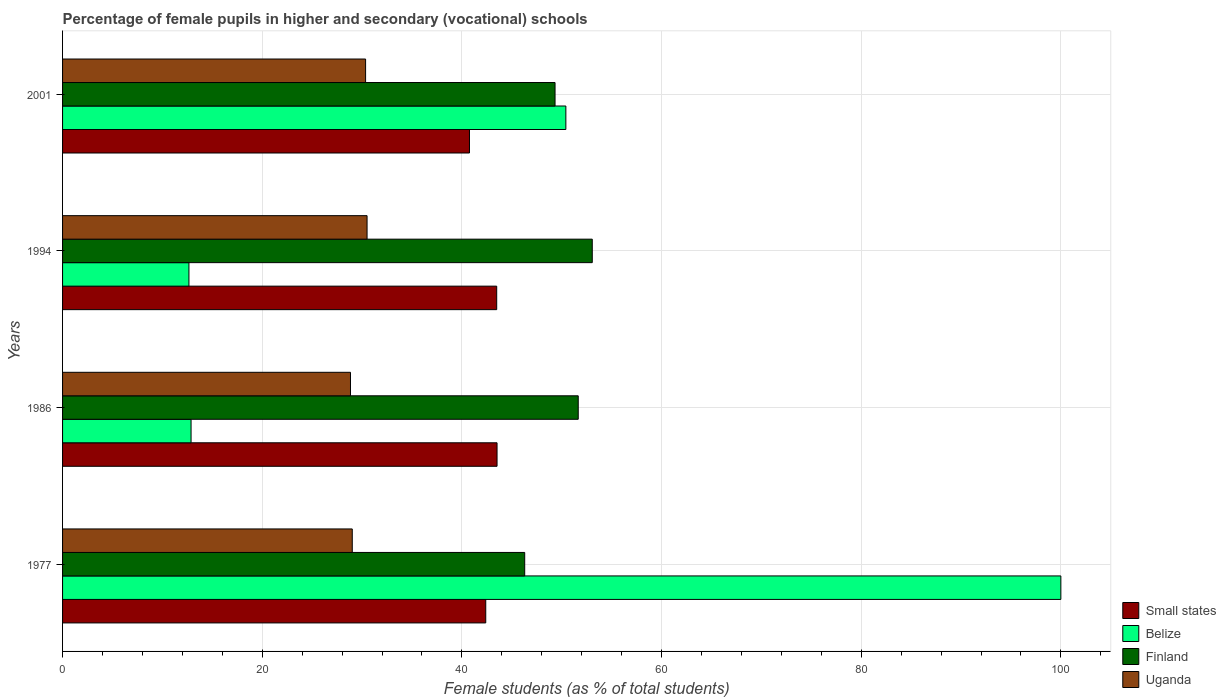Are the number of bars per tick equal to the number of legend labels?
Your answer should be very brief. Yes. Are the number of bars on each tick of the Y-axis equal?
Your response must be concise. Yes. What is the label of the 1st group of bars from the top?
Provide a short and direct response. 2001. In how many cases, is the number of bars for a given year not equal to the number of legend labels?
Provide a short and direct response. 0. What is the percentage of female pupils in higher and secondary schools in Uganda in 1977?
Offer a very short reply. 29.02. Across all years, what is the maximum percentage of female pupils in higher and secondary schools in Small states?
Offer a very short reply. 43.52. Across all years, what is the minimum percentage of female pupils in higher and secondary schools in Belize?
Keep it short and to the point. 12.66. In which year was the percentage of female pupils in higher and secondary schools in Belize maximum?
Provide a succinct answer. 1977. In which year was the percentage of female pupils in higher and secondary schools in Belize minimum?
Give a very brief answer. 1994. What is the total percentage of female pupils in higher and secondary schools in Uganda in the graph?
Your response must be concise. 118.72. What is the difference between the percentage of female pupils in higher and secondary schools in Uganda in 1977 and that in 1986?
Keep it short and to the point. 0.18. What is the difference between the percentage of female pupils in higher and secondary schools in Belize in 1994 and the percentage of female pupils in higher and secondary schools in Small states in 1986?
Keep it short and to the point. -30.86. What is the average percentage of female pupils in higher and secondary schools in Small states per year?
Give a very brief answer. 42.54. In the year 1986, what is the difference between the percentage of female pupils in higher and secondary schools in Finland and percentage of female pupils in higher and secondary schools in Uganda?
Provide a succinct answer. 22.81. What is the ratio of the percentage of female pupils in higher and secondary schools in Small states in 1977 to that in 2001?
Offer a terse response. 1.04. What is the difference between the highest and the second highest percentage of female pupils in higher and secondary schools in Small states?
Offer a terse response. 0.03. What is the difference between the highest and the lowest percentage of female pupils in higher and secondary schools in Belize?
Ensure brevity in your answer.  87.34. What does the 3rd bar from the top in 1994 represents?
Your response must be concise. Belize. What does the 4th bar from the bottom in 1977 represents?
Your answer should be compact. Uganda. Is it the case that in every year, the sum of the percentage of female pupils in higher and secondary schools in Belize and percentage of female pupils in higher and secondary schools in Finland is greater than the percentage of female pupils in higher and secondary schools in Small states?
Your answer should be very brief. Yes. How many bars are there?
Your response must be concise. 16. What is the difference between two consecutive major ticks on the X-axis?
Offer a terse response. 20. Does the graph contain any zero values?
Provide a short and direct response. No. How many legend labels are there?
Keep it short and to the point. 4. How are the legend labels stacked?
Make the answer very short. Vertical. What is the title of the graph?
Your answer should be compact. Percentage of female pupils in higher and secondary (vocational) schools. What is the label or title of the X-axis?
Your answer should be compact. Female students (as % of total students). What is the Female students (as % of total students) of Small states in 1977?
Your response must be concise. 42.39. What is the Female students (as % of total students) in Belize in 1977?
Your answer should be very brief. 100. What is the Female students (as % of total students) of Finland in 1977?
Offer a very short reply. 46.29. What is the Female students (as % of total students) of Uganda in 1977?
Your answer should be compact. 29.02. What is the Female students (as % of total students) of Small states in 1986?
Your answer should be very brief. 43.52. What is the Female students (as % of total students) in Belize in 1986?
Offer a terse response. 12.87. What is the Female students (as % of total students) in Finland in 1986?
Offer a very short reply. 51.65. What is the Female students (as % of total students) in Uganda in 1986?
Offer a terse response. 28.84. What is the Female students (as % of total students) in Small states in 1994?
Offer a terse response. 43.49. What is the Female students (as % of total students) in Belize in 1994?
Make the answer very short. 12.66. What is the Female students (as % of total students) in Finland in 1994?
Provide a short and direct response. 53.06. What is the Female students (as % of total students) in Uganda in 1994?
Ensure brevity in your answer.  30.5. What is the Female students (as % of total students) in Small states in 2001?
Your answer should be compact. 40.76. What is the Female students (as % of total students) in Belize in 2001?
Offer a very short reply. 50.41. What is the Female students (as % of total students) of Finland in 2001?
Your answer should be very brief. 49.33. What is the Female students (as % of total students) in Uganda in 2001?
Give a very brief answer. 30.35. Across all years, what is the maximum Female students (as % of total students) of Small states?
Make the answer very short. 43.52. Across all years, what is the maximum Female students (as % of total students) in Belize?
Your answer should be very brief. 100. Across all years, what is the maximum Female students (as % of total students) in Finland?
Give a very brief answer. 53.06. Across all years, what is the maximum Female students (as % of total students) of Uganda?
Your answer should be very brief. 30.5. Across all years, what is the minimum Female students (as % of total students) of Small states?
Give a very brief answer. 40.76. Across all years, what is the minimum Female students (as % of total students) in Belize?
Offer a very short reply. 12.66. Across all years, what is the minimum Female students (as % of total students) in Finland?
Make the answer very short. 46.29. Across all years, what is the minimum Female students (as % of total students) in Uganda?
Ensure brevity in your answer.  28.84. What is the total Female students (as % of total students) of Small states in the graph?
Make the answer very short. 170.16. What is the total Female students (as % of total students) of Belize in the graph?
Your answer should be very brief. 175.94. What is the total Female students (as % of total students) in Finland in the graph?
Provide a succinct answer. 200.34. What is the total Female students (as % of total students) of Uganda in the graph?
Your answer should be compact. 118.72. What is the difference between the Female students (as % of total students) of Small states in 1977 and that in 1986?
Your answer should be very brief. -1.13. What is the difference between the Female students (as % of total students) in Belize in 1977 and that in 1986?
Offer a terse response. 87.13. What is the difference between the Female students (as % of total students) in Finland in 1977 and that in 1986?
Make the answer very short. -5.36. What is the difference between the Female students (as % of total students) in Uganda in 1977 and that in 1986?
Provide a succinct answer. 0.18. What is the difference between the Female students (as % of total students) of Small states in 1977 and that in 1994?
Your answer should be very brief. -1.1. What is the difference between the Female students (as % of total students) in Belize in 1977 and that in 1994?
Give a very brief answer. 87.34. What is the difference between the Female students (as % of total students) in Finland in 1977 and that in 1994?
Offer a terse response. -6.77. What is the difference between the Female students (as % of total students) of Uganda in 1977 and that in 1994?
Provide a succinct answer. -1.48. What is the difference between the Female students (as % of total students) in Small states in 1977 and that in 2001?
Make the answer very short. 1.63. What is the difference between the Female students (as % of total students) in Belize in 1977 and that in 2001?
Provide a short and direct response. 49.59. What is the difference between the Female students (as % of total students) of Finland in 1977 and that in 2001?
Your answer should be compact. -3.04. What is the difference between the Female students (as % of total students) of Uganda in 1977 and that in 2001?
Make the answer very short. -1.33. What is the difference between the Female students (as % of total students) of Small states in 1986 and that in 1994?
Ensure brevity in your answer.  0.03. What is the difference between the Female students (as % of total students) in Belize in 1986 and that in 1994?
Your answer should be compact. 0.21. What is the difference between the Female students (as % of total students) of Finland in 1986 and that in 1994?
Offer a very short reply. -1.41. What is the difference between the Female students (as % of total students) in Uganda in 1986 and that in 1994?
Offer a terse response. -1.66. What is the difference between the Female students (as % of total students) in Small states in 1986 and that in 2001?
Make the answer very short. 2.76. What is the difference between the Female students (as % of total students) of Belize in 1986 and that in 2001?
Your answer should be compact. -37.54. What is the difference between the Female students (as % of total students) of Finland in 1986 and that in 2001?
Provide a short and direct response. 2.32. What is the difference between the Female students (as % of total students) of Uganda in 1986 and that in 2001?
Ensure brevity in your answer.  -1.51. What is the difference between the Female students (as % of total students) of Small states in 1994 and that in 2001?
Provide a succinct answer. 2.73. What is the difference between the Female students (as % of total students) of Belize in 1994 and that in 2001?
Your response must be concise. -37.76. What is the difference between the Female students (as % of total students) in Finland in 1994 and that in 2001?
Your answer should be compact. 3.73. What is the difference between the Female students (as % of total students) of Uganda in 1994 and that in 2001?
Your answer should be very brief. 0.15. What is the difference between the Female students (as % of total students) of Small states in 1977 and the Female students (as % of total students) of Belize in 1986?
Your answer should be very brief. 29.52. What is the difference between the Female students (as % of total students) of Small states in 1977 and the Female students (as % of total students) of Finland in 1986?
Give a very brief answer. -9.26. What is the difference between the Female students (as % of total students) in Small states in 1977 and the Female students (as % of total students) in Uganda in 1986?
Ensure brevity in your answer.  13.55. What is the difference between the Female students (as % of total students) of Belize in 1977 and the Female students (as % of total students) of Finland in 1986?
Your answer should be very brief. 48.35. What is the difference between the Female students (as % of total students) in Belize in 1977 and the Female students (as % of total students) in Uganda in 1986?
Offer a terse response. 71.16. What is the difference between the Female students (as % of total students) of Finland in 1977 and the Female students (as % of total students) of Uganda in 1986?
Your answer should be very brief. 17.45. What is the difference between the Female students (as % of total students) in Small states in 1977 and the Female students (as % of total students) in Belize in 1994?
Your answer should be compact. 29.73. What is the difference between the Female students (as % of total students) in Small states in 1977 and the Female students (as % of total students) in Finland in 1994?
Ensure brevity in your answer.  -10.67. What is the difference between the Female students (as % of total students) of Small states in 1977 and the Female students (as % of total students) of Uganda in 1994?
Your answer should be very brief. 11.89. What is the difference between the Female students (as % of total students) in Belize in 1977 and the Female students (as % of total students) in Finland in 1994?
Provide a succinct answer. 46.94. What is the difference between the Female students (as % of total students) of Belize in 1977 and the Female students (as % of total students) of Uganda in 1994?
Your answer should be compact. 69.5. What is the difference between the Female students (as % of total students) in Finland in 1977 and the Female students (as % of total students) in Uganda in 1994?
Your response must be concise. 15.79. What is the difference between the Female students (as % of total students) of Small states in 1977 and the Female students (as % of total students) of Belize in 2001?
Make the answer very short. -8.02. What is the difference between the Female students (as % of total students) of Small states in 1977 and the Female students (as % of total students) of Finland in 2001?
Your answer should be compact. -6.94. What is the difference between the Female students (as % of total students) of Small states in 1977 and the Female students (as % of total students) of Uganda in 2001?
Provide a short and direct response. 12.04. What is the difference between the Female students (as % of total students) of Belize in 1977 and the Female students (as % of total students) of Finland in 2001?
Keep it short and to the point. 50.67. What is the difference between the Female students (as % of total students) in Belize in 1977 and the Female students (as % of total students) in Uganda in 2001?
Keep it short and to the point. 69.65. What is the difference between the Female students (as % of total students) in Finland in 1977 and the Female students (as % of total students) in Uganda in 2001?
Your answer should be compact. 15.94. What is the difference between the Female students (as % of total students) of Small states in 1986 and the Female students (as % of total students) of Belize in 1994?
Offer a terse response. 30.86. What is the difference between the Female students (as % of total students) in Small states in 1986 and the Female students (as % of total students) in Finland in 1994?
Give a very brief answer. -9.54. What is the difference between the Female students (as % of total students) of Small states in 1986 and the Female students (as % of total students) of Uganda in 1994?
Ensure brevity in your answer.  13.02. What is the difference between the Female students (as % of total students) of Belize in 1986 and the Female students (as % of total students) of Finland in 1994?
Offer a very short reply. -40.19. What is the difference between the Female students (as % of total students) in Belize in 1986 and the Female students (as % of total students) in Uganda in 1994?
Offer a very short reply. -17.63. What is the difference between the Female students (as % of total students) of Finland in 1986 and the Female students (as % of total students) of Uganda in 1994?
Your answer should be very brief. 21.15. What is the difference between the Female students (as % of total students) in Small states in 1986 and the Female students (as % of total students) in Belize in 2001?
Offer a very short reply. -6.89. What is the difference between the Female students (as % of total students) in Small states in 1986 and the Female students (as % of total students) in Finland in 2001?
Keep it short and to the point. -5.81. What is the difference between the Female students (as % of total students) of Small states in 1986 and the Female students (as % of total students) of Uganda in 2001?
Your answer should be very brief. 13.17. What is the difference between the Female students (as % of total students) of Belize in 1986 and the Female students (as % of total students) of Finland in 2001?
Give a very brief answer. -36.46. What is the difference between the Female students (as % of total students) of Belize in 1986 and the Female students (as % of total students) of Uganda in 2001?
Give a very brief answer. -17.48. What is the difference between the Female students (as % of total students) in Finland in 1986 and the Female students (as % of total students) in Uganda in 2001?
Give a very brief answer. 21.3. What is the difference between the Female students (as % of total students) in Small states in 1994 and the Female students (as % of total students) in Belize in 2001?
Offer a very short reply. -6.93. What is the difference between the Female students (as % of total students) in Small states in 1994 and the Female students (as % of total students) in Finland in 2001?
Offer a terse response. -5.84. What is the difference between the Female students (as % of total students) in Small states in 1994 and the Female students (as % of total students) in Uganda in 2001?
Offer a very short reply. 13.13. What is the difference between the Female students (as % of total students) in Belize in 1994 and the Female students (as % of total students) in Finland in 2001?
Keep it short and to the point. -36.67. What is the difference between the Female students (as % of total students) of Belize in 1994 and the Female students (as % of total students) of Uganda in 2001?
Offer a very short reply. -17.7. What is the difference between the Female students (as % of total students) of Finland in 1994 and the Female students (as % of total students) of Uganda in 2001?
Provide a succinct answer. 22.71. What is the average Female students (as % of total students) in Small states per year?
Give a very brief answer. 42.54. What is the average Female students (as % of total students) of Belize per year?
Make the answer very short. 43.99. What is the average Female students (as % of total students) in Finland per year?
Offer a very short reply. 50.09. What is the average Female students (as % of total students) of Uganda per year?
Your answer should be very brief. 29.68. In the year 1977, what is the difference between the Female students (as % of total students) of Small states and Female students (as % of total students) of Belize?
Ensure brevity in your answer.  -57.61. In the year 1977, what is the difference between the Female students (as % of total students) in Small states and Female students (as % of total students) in Finland?
Make the answer very short. -3.9. In the year 1977, what is the difference between the Female students (as % of total students) in Small states and Female students (as % of total students) in Uganda?
Give a very brief answer. 13.37. In the year 1977, what is the difference between the Female students (as % of total students) in Belize and Female students (as % of total students) in Finland?
Make the answer very short. 53.71. In the year 1977, what is the difference between the Female students (as % of total students) in Belize and Female students (as % of total students) in Uganda?
Your response must be concise. 70.98. In the year 1977, what is the difference between the Female students (as % of total students) in Finland and Female students (as % of total students) in Uganda?
Offer a terse response. 17.27. In the year 1986, what is the difference between the Female students (as % of total students) in Small states and Female students (as % of total students) in Belize?
Offer a terse response. 30.65. In the year 1986, what is the difference between the Female students (as % of total students) in Small states and Female students (as % of total students) in Finland?
Keep it short and to the point. -8.13. In the year 1986, what is the difference between the Female students (as % of total students) in Small states and Female students (as % of total students) in Uganda?
Your answer should be very brief. 14.68. In the year 1986, what is the difference between the Female students (as % of total students) of Belize and Female students (as % of total students) of Finland?
Your answer should be compact. -38.78. In the year 1986, what is the difference between the Female students (as % of total students) in Belize and Female students (as % of total students) in Uganda?
Offer a very short reply. -15.97. In the year 1986, what is the difference between the Female students (as % of total students) in Finland and Female students (as % of total students) in Uganda?
Keep it short and to the point. 22.81. In the year 1994, what is the difference between the Female students (as % of total students) in Small states and Female students (as % of total students) in Belize?
Make the answer very short. 30.83. In the year 1994, what is the difference between the Female students (as % of total students) in Small states and Female students (as % of total students) in Finland?
Ensure brevity in your answer.  -9.57. In the year 1994, what is the difference between the Female students (as % of total students) in Small states and Female students (as % of total students) in Uganda?
Your response must be concise. 12.99. In the year 1994, what is the difference between the Female students (as % of total students) in Belize and Female students (as % of total students) in Finland?
Your response must be concise. -40.4. In the year 1994, what is the difference between the Female students (as % of total students) in Belize and Female students (as % of total students) in Uganda?
Ensure brevity in your answer.  -17.84. In the year 1994, what is the difference between the Female students (as % of total students) in Finland and Female students (as % of total students) in Uganda?
Give a very brief answer. 22.56. In the year 2001, what is the difference between the Female students (as % of total students) of Small states and Female students (as % of total students) of Belize?
Provide a succinct answer. -9.65. In the year 2001, what is the difference between the Female students (as % of total students) in Small states and Female students (as % of total students) in Finland?
Give a very brief answer. -8.57. In the year 2001, what is the difference between the Female students (as % of total students) in Small states and Female students (as % of total students) in Uganda?
Your answer should be very brief. 10.41. In the year 2001, what is the difference between the Female students (as % of total students) of Belize and Female students (as % of total students) of Finland?
Provide a short and direct response. 1.08. In the year 2001, what is the difference between the Female students (as % of total students) in Belize and Female students (as % of total students) in Uganda?
Ensure brevity in your answer.  20.06. In the year 2001, what is the difference between the Female students (as % of total students) of Finland and Female students (as % of total students) of Uganda?
Offer a terse response. 18.98. What is the ratio of the Female students (as % of total students) in Belize in 1977 to that in 1986?
Your answer should be very brief. 7.77. What is the ratio of the Female students (as % of total students) in Finland in 1977 to that in 1986?
Provide a succinct answer. 0.9. What is the ratio of the Female students (as % of total students) in Small states in 1977 to that in 1994?
Your response must be concise. 0.97. What is the ratio of the Female students (as % of total students) in Belize in 1977 to that in 1994?
Provide a short and direct response. 7.9. What is the ratio of the Female students (as % of total students) of Finland in 1977 to that in 1994?
Your answer should be very brief. 0.87. What is the ratio of the Female students (as % of total students) in Uganda in 1977 to that in 1994?
Keep it short and to the point. 0.95. What is the ratio of the Female students (as % of total students) in Small states in 1977 to that in 2001?
Offer a very short reply. 1.04. What is the ratio of the Female students (as % of total students) of Belize in 1977 to that in 2001?
Provide a short and direct response. 1.98. What is the ratio of the Female students (as % of total students) in Finland in 1977 to that in 2001?
Provide a short and direct response. 0.94. What is the ratio of the Female students (as % of total students) in Uganda in 1977 to that in 2001?
Give a very brief answer. 0.96. What is the ratio of the Female students (as % of total students) of Belize in 1986 to that in 1994?
Keep it short and to the point. 1.02. What is the ratio of the Female students (as % of total students) of Finland in 1986 to that in 1994?
Your response must be concise. 0.97. What is the ratio of the Female students (as % of total students) in Uganda in 1986 to that in 1994?
Your answer should be compact. 0.95. What is the ratio of the Female students (as % of total students) in Small states in 1986 to that in 2001?
Your answer should be very brief. 1.07. What is the ratio of the Female students (as % of total students) of Belize in 1986 to that in 2001?
Offer a very short reply. 0.26. What is the ratio of the Female students (as % of total students) of Finland in 1986 to that in 2001?
Your response must be concise. 1.05. What is the ratio of the Female students (as % of total students) of Uganda in 1986 to that in 2001?
Offer a terse response. 0.95. What is the ratio of the Female students (as % of total students) of Small states in 1994 to that in 2001?
Provide a succinct answer. 1.07. What is the ratio of the Female students (as % of total students) in Belize in 1994 to that in 2001?
Ensure brevity in your answer.  0.25. What is the ratio of the Female students (as % of total students) in Finland in 1994 to that in 2001?
Offer a terse response. 1.08. What is the difference between the highest and the second highest Female students (as % of total students) in Small states?
Offer a very short reply. 0.03. What is the difference between the highest and the second highest Female students (as % of total students) in Belize?
Your answer should be very brief. 49.59. What is the difference between the highest and the second highest Female students (as % of total students) in Finland?
Your answer should be very brief. 1.41. What is the difference between the highest and the second highest Female students (as % of total students) of Uganda?
Offer a terse response. 0.15. What is the difference between the highest and the lowest Female students (as % of total students) in Small states?
Provide a short and direct response. 2.76. What is the difference between the highest and the lowest Female students (as % of total students) of Belize?
Give a very brief answer. 87.34. What is the difference between the highest and the lowest Female students (as % of total students) of Finland?
Provide a succinct answer. 6.77. What is the difference between the highest and the lowest Female students (as % of total students) of Uganda?
Your answer should be compact. 1.66. 